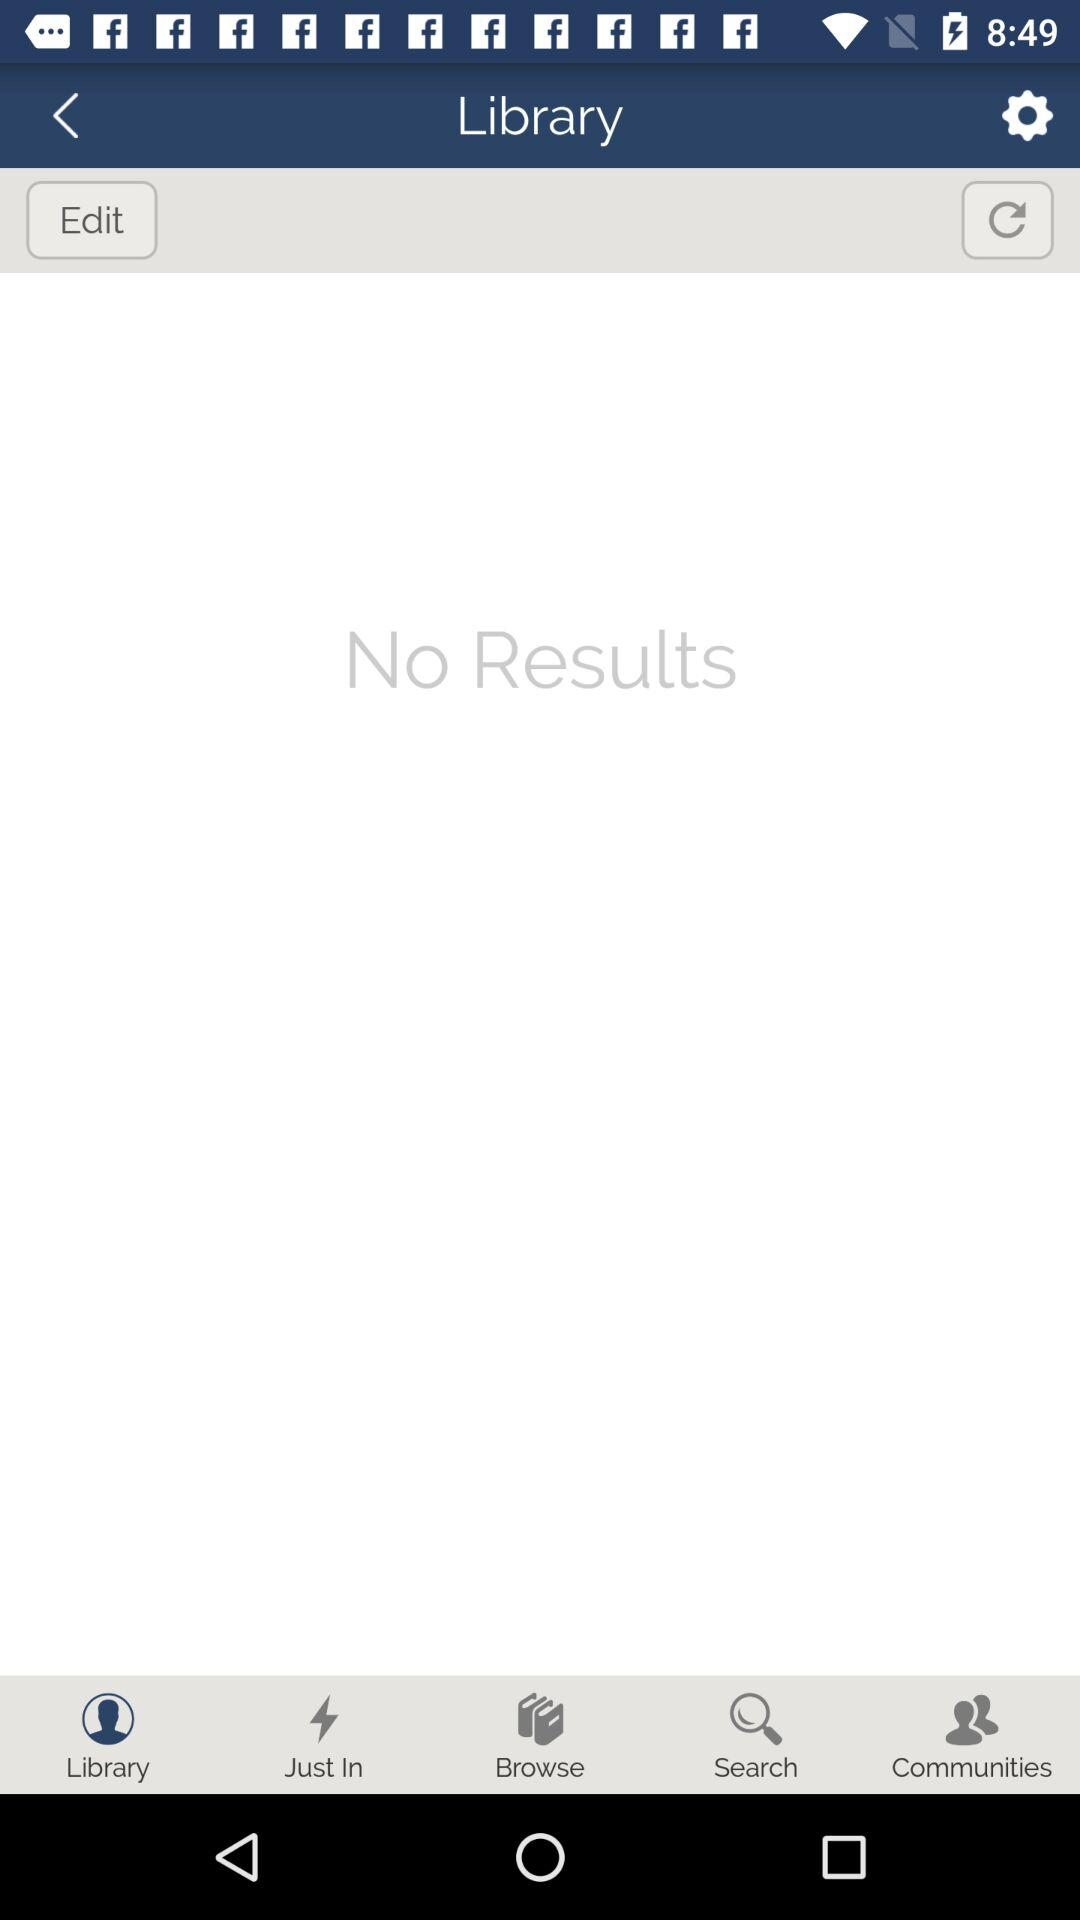Which tab is selected? The selected tab is "Library". 